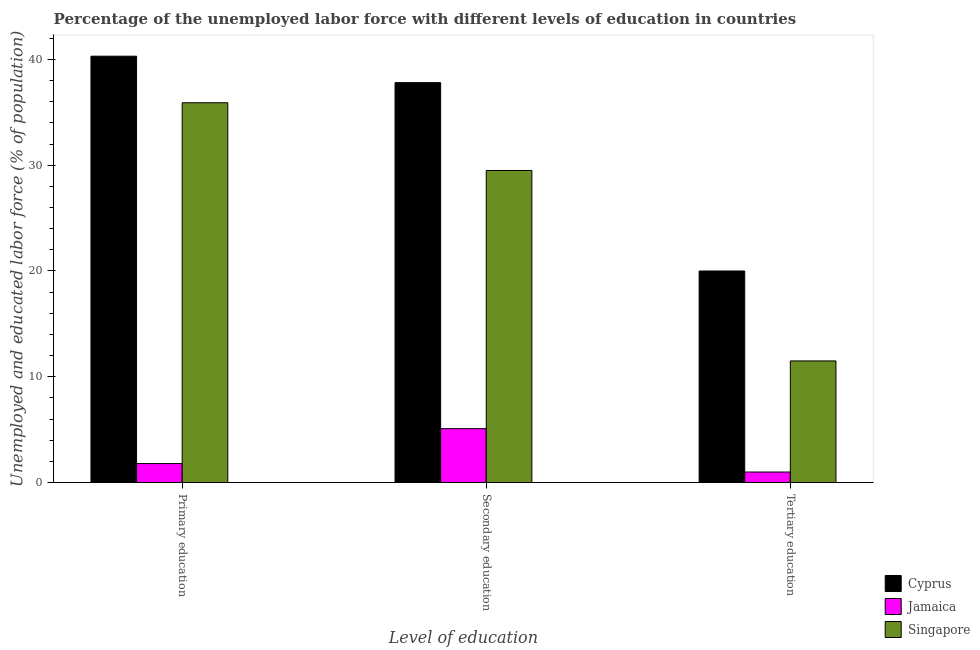How many different coloured bars are there?
Ensure brevity in your answer.  3. How many groups of bars are there?
Keep it short and to the point. 3. Are the number of bars on each tick of the X-axis equal?
Ensure brevity in your answer.  Yes. What is the label of the 3rd group of bars from the left?
Your response must be concise. Tertiary education. What is the percentage of labor force who received primary education in Jamaica?
Your response must be concise. 1.8. Across all countries, what is the maximum percentage of labor force who received tertiary education?
Offer a very short reply. 20. Across all countries, what is the minimum percentage of labor force who received secondary education?
Provide a short and direct response. 5.1. In which country was the percentage of labor force who received secondary education maximum?
Provide a short and direct response. Cyprus. In which country was the percentage of labor force who received primary education minimum?
Offer a very short reply. Jamaica. What is the total percentage of labor force who received tertiary education in the graph?
Provide a succinct answer. 32.5. What is the difference between the percentage of labor force who received tertiary education in Cyprus and the percentage of labor force who received secondary education in Jamaica?
Ensure brevity in your answer.  14.9. What is the average percentage of labor force who received secondary education per country?
Offer a very short reply. 24.13. What is the difference between the percentage of labor force who received primary education and percentage of labor force who received secondary education in Cyprus?
Provide a short and direct response. 2.5. In how many countries, is the percentage of labor force who received tertiary education greater than 28 %?
Ensure brevity in your answer.  0. What is the ratio of the percentage of labor force who received secondary education in Jamaica to that in Cyprus?
Offer a terse response. 0.13. Is the difference between the percentage of labor force who received tertiary education in Jamaica and Cyprus greater than the difference between the percentage of labor force who received secondary education in Jamaica and Cyprus?
Keep it short and to the point. Yes. What is the difference between the highest and the second highest percentage of labor force who received primary education?
Provide a short and direct response. 4.4. What is the difference between the highest and the lowest percentage of labor force who received primary education?
Your answer should be very brief. 38.5. In how many countries, is the percentage of labor force who received secondary education greater than the average percentage of labor force who received secondary education taken over all countries?
Keep it short and to the point. 2. What does the 3rd bar from the left in Primary education represents?
Offer a very short reply. Singapore. What does the 1st bar from the right in Primary education represents?
Offer a very short reply. Singapore. Is it the case that in every country, the sum of the percentage of labor force who received primary education and percentage of labor force who received secondary education is greater than the percentage of labor force who received tertiary education?
Make the answer very short. Yes. How many bars are there?
Provide a short and direct response. 9. Are the values on the major ticks of Y-axis written in scientific E-notation?
Offer a terse response. No. Where does the legend appear in the graph?
Your answer should be very brief. Bottom right. How many legend labels are there?
Offer a terse response. 3. What is the title of the graph?
Ensure brevity in your answer.  Percentage of the unemployed labor force with different levels of education in countries. What is the label or title of the X-axis?
Offer a terse response. Level of education. What is the label or title of the Y-axis?
Provide a short and direct response. Unemployed and educated labor force (% of population). What is the Unemployed and educated labor force (% of population) in Cyprus in Primary education?
Give a very brief answer. 40.3. What is the Unemployed and educated labor force (% of population) in Jamaica in Primary education?
Provide a short and direct response. 1.8. What is the Unemployed and educated labor force (% of population) of Singapore in Primary education?
Your answer should be compact. 35.9. What is the Unemployed and educated labor force (% of population) of Cyprus in Secondary education?
Offer a terse response. 37.8. What is the Unemployed and educated labor force (% of population) in Jamaica in Secondary education?
Your answer should be very brief. 5.1. What is the Unemployed and educated labor force (% of population) in Singapore in Secondary education?
Offer a terse response. 29.5. What is the Unemployed and educated labor force (% of population) of Singapore in Tertiary education?
Provide a short and direct response. 11.5. Across all Level of education, what is the maximum Unemployed and educated labor force (% of population) in Cyprus?
Give a very brief answer. 40.3. Across all Level of education, what is the maximum Unemployed and educated labor force (% of population) in Jamaica?
Your answer should be very brief. 5.1. Across all Level of education, what is the maximum Unemployed and educated labor force (% of population) of Singapore?
Offer a terse response. 35.9. Across all Level of education, what is the minimum Unemployed and educated labor force (% of population) of Jamaica?
Offer a terse response. 1. Across all Level of education, what is the minimum Unemployed and educated labor force (% of population) of Singapore?
Your response must be concise. 11.5. What is the total Unemployed and educated labor force (% of population) of Cyprus in the graph?
Your answer should be very brief. 98.1. What is the total Unemployed and educated labor force (% of population) of Singapore in the graph?
Your answer should be very brief. 76.9. What is the difference between the Unemployed and educated labor force (% of population) in Cyprus in Primary education and that in Secondary education?
Offer a very short reply. 2.5. What is the difference between the Unemployed and educated labor force (% of population) of Singapore in Primary education and that in Secondary education?
Your answer should be very brief. 6.4. What is the difference between the Unemployed and educated labor force (% of population) of Cyprus in Primary education and that in Tertiary education?
Keep it short and to the point. 20.3. What is the difference between the Unemployed and educated labor force (% of population) of Singapore in Primary education and that in Tertiary education?
Your response must be concise. 24.4. What is the difference between the Unemployed and educated labor force (% of population) of Cyprus in Secondary education and that in Tertiary education?
Offer a very short reply. 17.8. What is the difference between the Unemployed and educated labor force (% of population) of Jamaica in Secondary education and that in Tertiary education?
Offer a very short reply. 4.1. What is the difference between the Unemployed and educated labor force (% of population) in Cyprus in Primary education and the Unemployed and educated labor force (% of population) in Jamaica in Secondary education?
Provide a short and direct response. 35.2. What is the difference between the Unemployed and educated labor force (% of population) of Cyprus in Primary education and the Unemployed and educated labor force (% of population) of Singapore in Secondary education?
Your answer should be compact. 10.8. What is the difference between the Unemployed and educated labor force (% of population) of Jamaica in Primary education and the Unemployed and educated labor force (% of population) of Singapore in Secondary education?
Offer a very short reply. -27.7. What is the difference between the Unemployed and educated labor force (% of population) of Cyprus in Primary education and the Unemployed and educated labor force (% of population) of Jamaica in Tertiary education?
Give a very brief answer. 39.3. What is the difference between the Unemployed and educated labor force (% of population) in Cyprus in Primary education and the Unemployed and educated labor force (% of population) in Singapore in Tertiary education?
Offer a very short reply. 28.8. What is the difference between the Unemployed and educated labor force (% of population) of Jamaica in Primary education and the Unemployed and educated labor force (% of population) of Singapore in Tertiary education?
Your response must be concise. -9.7. What is the difference between the Unemployed and educated labor force (% of population) of Cyprus in Secondary education and the Unemployed and educated labor force (% of population) of Jamaica in Tertiary education?
Ensure brevity in your answer.  36.8. What is the difference between the Unemployed and educated labor force (% of population) of Cyprus in Secondary education and the Unemployed and educated labor force (% of population) of Singapore in Tertiary education?
Provide a short and direct response. 26.3. What is the average Unemployed and educated labor force (% of population) in Cyprus per Level of education?
Give a very brief answer. 32.7. What is the average Unemployed and educated labor force (% of population) of Jamaica per Level of education?
Ensure brevity in your answer.  2.63. What is the average Unemployed and educated labor force (% of population) in Singapore per Level of education?
Your answer should be compact. 25.63. What is the difference between the Unemployed and educated labor force (% of population) in Cyprus and Unemployed and educated labor force (% of population) in Jamaica in Primary education?
Your response must be concise. 38.5. What is the difference between the Unemployed and educated labor force (% of population) of Cyprus and Unemployed and educated labor force (% of population) of Singapore in Primary education?
Give a very brief answer. 4.4. What is the difference between the Unemployed and educated labor force (% of population) of Jamaica and Unemployed and educated labor force (% of population) of Singapore in Primary education?
Ensure brevity in your answer.  -34.1. What is the difference between the Unemployed and educated labor force (% of population) of Cyprus and Unemployed and educated labor force (% of population) of Jamaica in Secondary education?
Keep it short and to the point. 32.7. What is the difference between the Unemployed and educated labor force (% of population) of Jamaica and Unemployed and educated labor force (% of population) of Singapore in Secondary education?
Ensure brevity in your answer.  -24.4. What is the difference between the Unemployed and educated labor force (% of population) of Cyprus and Unemployed and educated labor force (% of population) of Jamaica in Tertiary education?
Provide a succinct answer. 19. What is the difference between the Unemployed and educated labor force (% of population) in Cyprus and Unemployed and educated labor force (% of population) in Singapore in Tertiary education?
Ensure brevity in your answer.  8.5. What is the difference between the Unemployed and educated labor force (% of population) in Jamaica and Unemployed and educated labor force (% of population) in Singapore in Tertiary education?
Your answer should be very brief. -10.5. What is the ratio of the Unemployed and educated labor force (% of population) in Cyprus in Primary education to that in Secondary education?
Your answer should be very brief. 1.07. What is the ratio of the Unemployed and educated labor force (% of population) in Jamaica in Primary education to that in Secondary education?
Ensure brevity in your answer.  0.35. What is the ratio of the Unemployed and educated labor force (% of population) of Singapore in Primary education to that in Secondary education?
Ensure brevity in your answer.  1.22. What is the ratio of the Unemployed and educated labor force (% of population) in Cyprus in Primary education to that in Tertiary education?
Ensure brevity in your answer.  2.02. What is the ratio of the Unemployed and educated labor force (% of population) in Singapore in Primary education to that in Tertiary education?
Provide a succinct answer. 3.12. What is the ratio of the Unemployed and educated labor force (% of population) of Cyprus in Secondary education to that in Tertiary education?
Your response must be concise. 1.89. What is the ratio of the Unemployed and educated labor force (% of population) in Jamaica in Secondary education to that in Tertiary education?
Your answer should be very brief. 5.1. What is the ratio of the Unemployed and educated labor force (% of population) of Singapore in Secondary education to that in Tertiary education?
Offer a very short reply. 2.57. What is the difference between the highest and the second highest Unemployed and educated labor force (% of population) of Cyprus?
Provide a short and direct response. 2.5. What is the difference between the highest and the lowest Unemployed and educated labor force (% of population) of Cyprus?
Your response must be concise. 20.3. What is the difference between the highest and the lowest Unemployed and educated labor force (% of population) in Singapore?
Offer a very short reply. 24.4. 